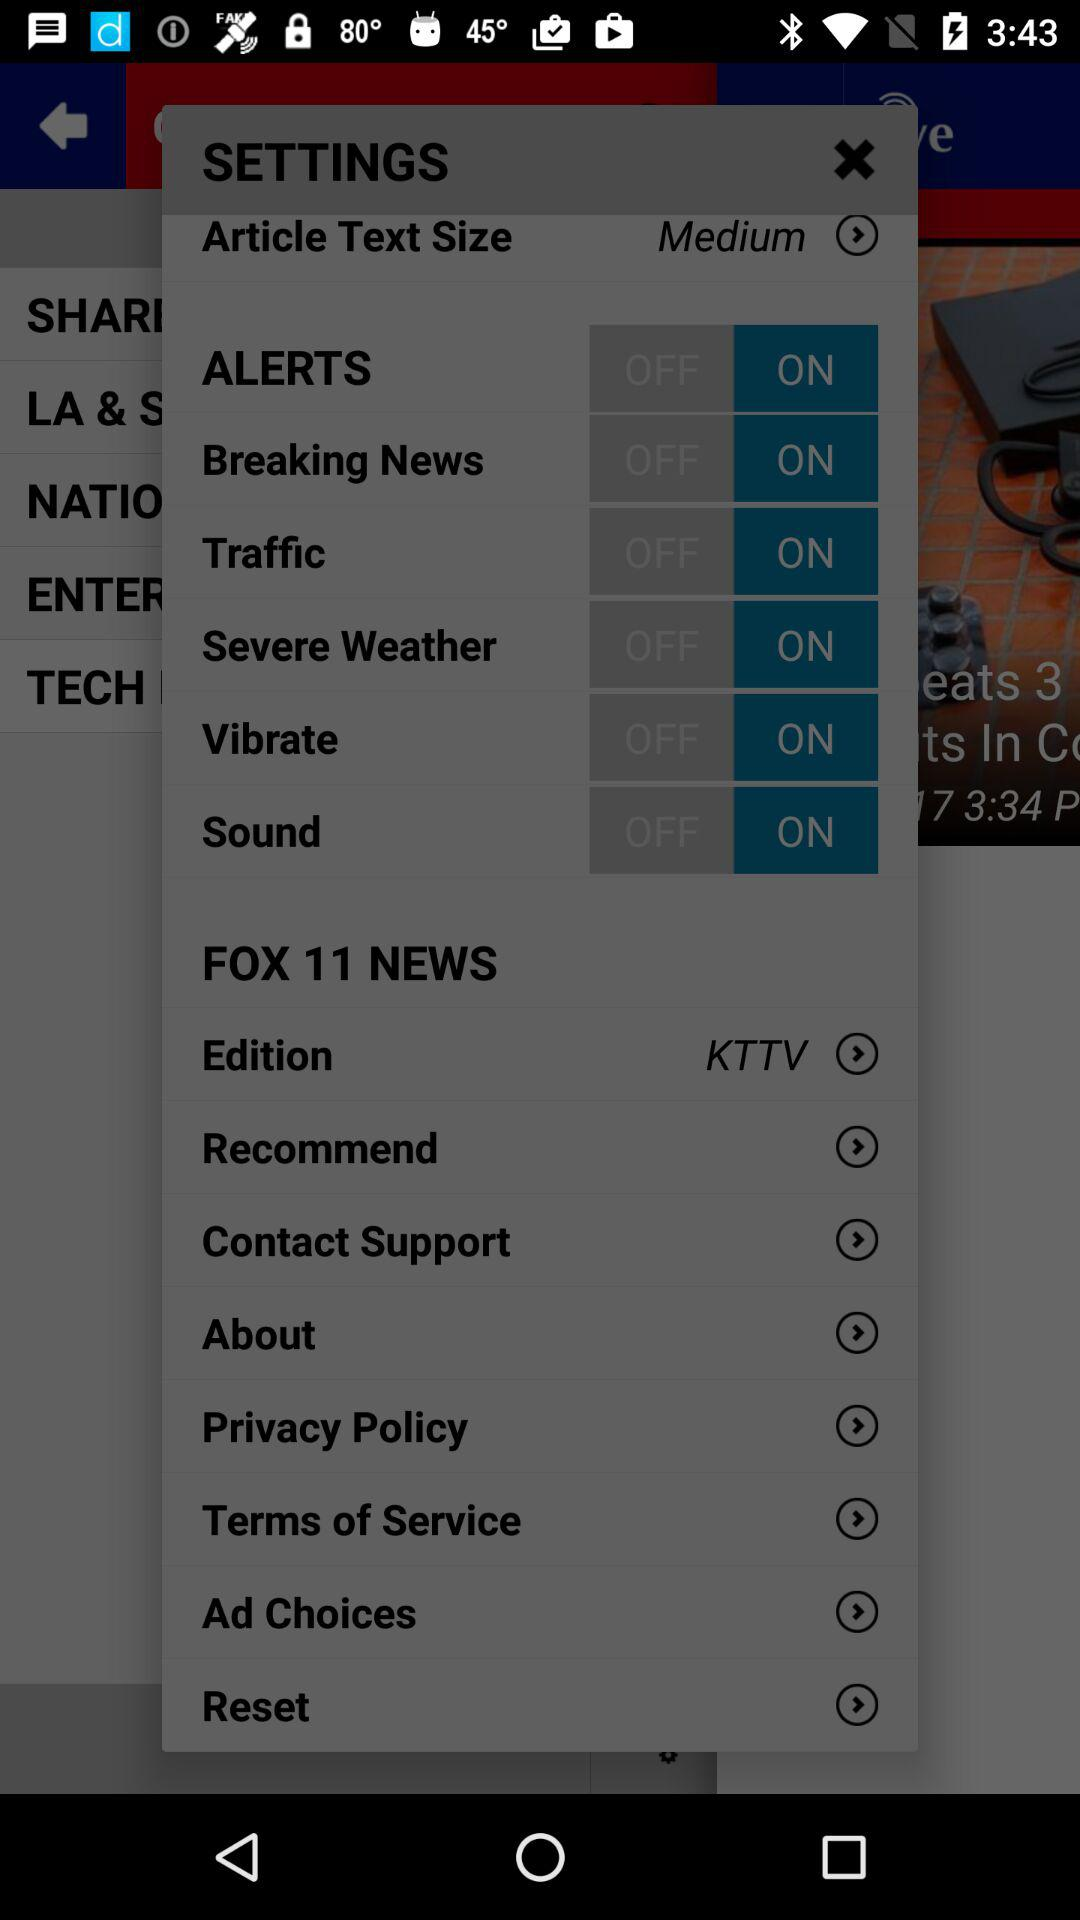What is the article text size? The article text size is "Medium". 